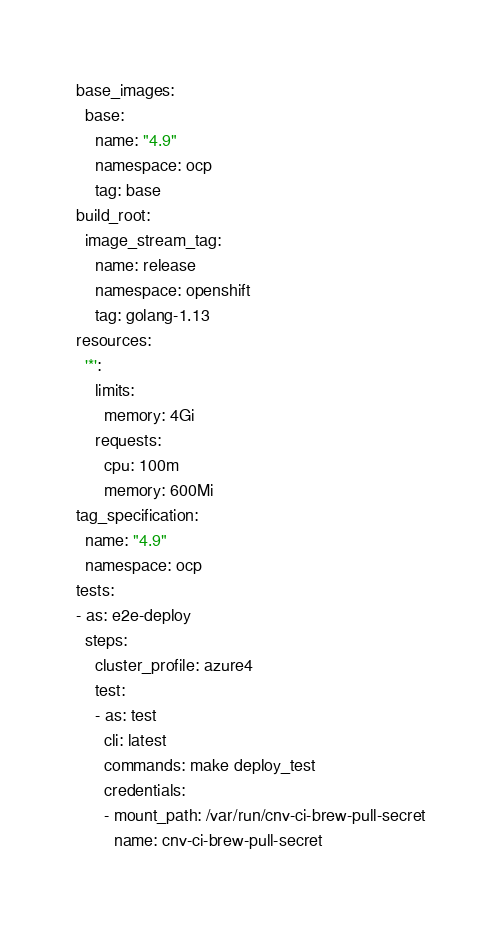Convert code to text. <code><loc_0><loc_0><loc_500><loc_500><_YAML_>base_images:
  base:
    name: "4.9"
    namespace: ocp
    tag: base
build_root:
  image_stream_tag:
    name: release
    namespace: openshift
    tag: golang-1.13
resources:
  '*':
    limits:
      memory: 4Gi
    requests:
      cpu: 100m
      memory: 600Mi
tag_specification:
  name: "4.9"
  namespace: ocp
tests:
- as: e2e-deploy
  steps:
    cluster_profile: azure4
    test:
    - as: test
      cli: latest
      commands: make deploy_test
      credentials:
      - mount_path: /var/run/cnv-ci-brew-pull-secret
        name: cnv-ci-brew-pull-secret</code> 